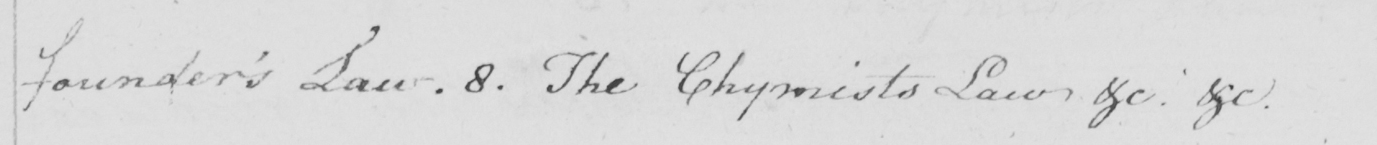Can you read and transcribe this handwriting? founder ' s Law . 8 . The Chymists Law &c . &c . 